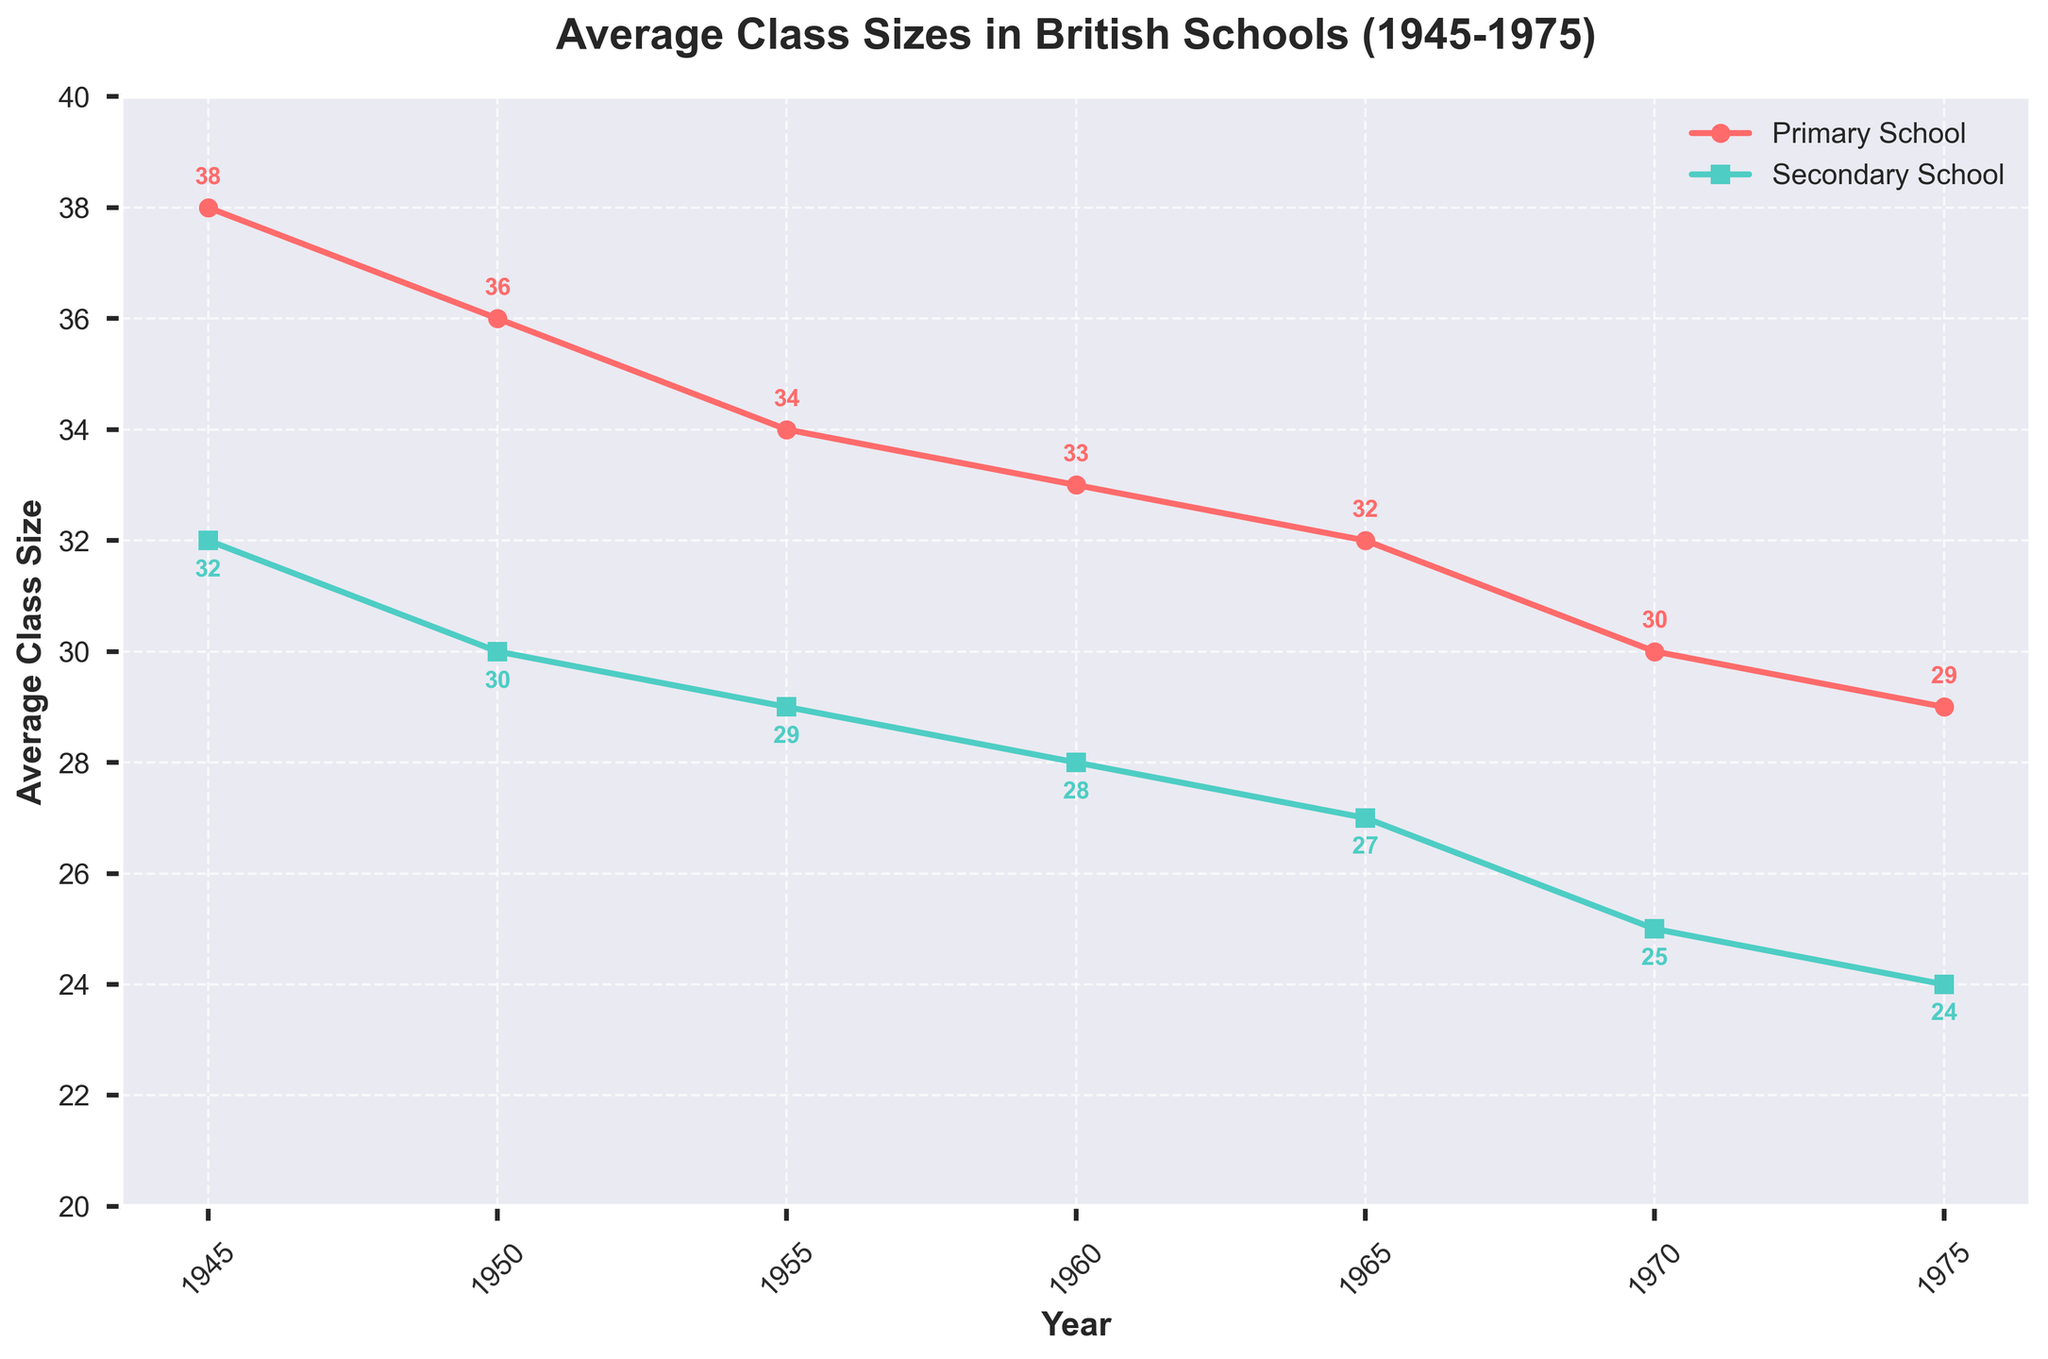What was the average class size in primary schools in 1945? Look at the value of the primary school line for the year 1945. It is labeled as 38.
Answer: 38 How much did the average class size in secondary schools decrease from 1945 to 1975? Subtract the average class size in secondary schools in 1975 from the value in 1945: 32 - 24 = 8.
Answer: 8 Which school type had a higher average class size in 1960? Compare the values for primary and secondary schools in 1960. Primary is 33 and secondary is 28, so primary is higher.
Answer: Primary By how many did the primary school class size decrease from 1945 to 1950? Subtract the average class size in 1950 from the value in 1945: 38 - 36 = 2.
Answer: 2 What trend is observed in the average class sizes for both primary and secondary schools from 1945 to 1975? Observe the overall direction of the lines for both primary and secondary schools. Both lines show a decreasing trend.
Answer: Decreasing What is the difference in average class sizes between primary and secondary schools in 1970? Subtract the average class size for secondary schools in 1970 from the value for primary schools in the same year: 30 - 25 = 5.
Answer: 5 In which year did primary schools first have an average class size below 35? Identify the first year the primary school line dips below 35. It is in 1955 when the size is 34.
Answer: 1955 Which school type showed a greater absolute reduction in average class size from 1945 to 1975? Calculate the absolute reduction for each school type and compare: Primary school: 38 - 29 = 9; Secondary school: 32 - 24 = 8. Therefore, primary schools had a greater reduction.
Answer: Primary What was the average class size in secondary schools in 1955? Look at the value of the secondary school line for the year 1955. It is labeled as 29.
Answer: 29 